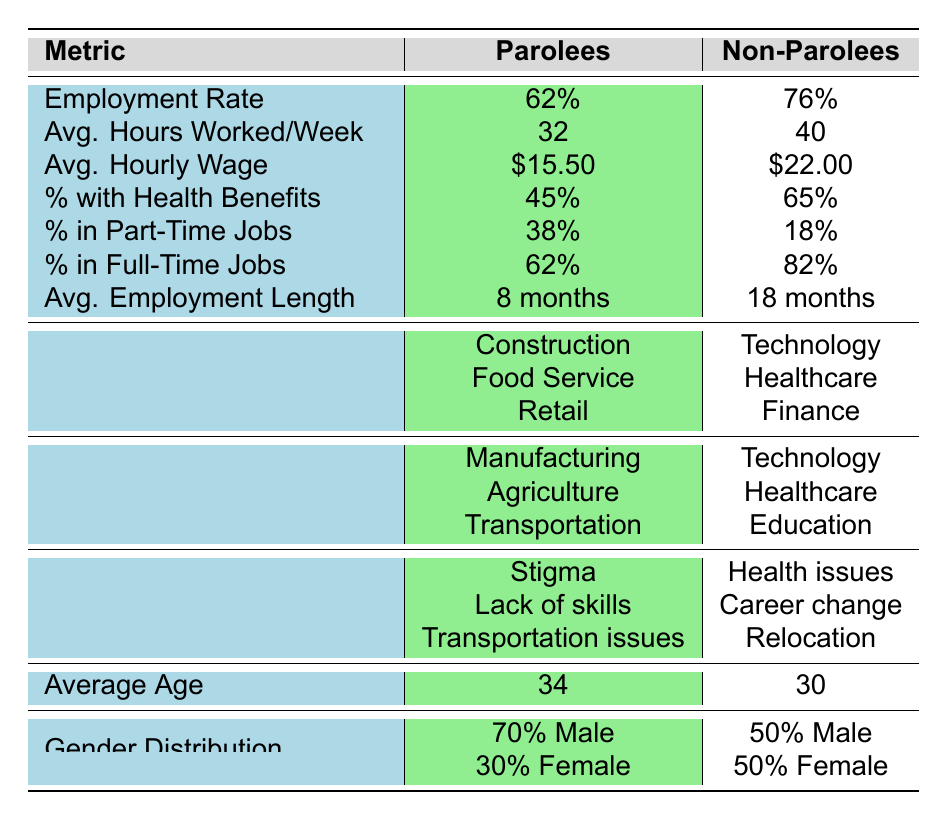What is the employment rate for parolees? The table lists the employment rate for parolees as 62%.
Answer: 62% How many hours do parolees work on average per week? According to the table, parolees work an average of 32 hours per week.
Answer: 32 hours What is the average hourly wage for non-parolees? The table shows that the average hourly wage for non-parolees is $22.00.
Answer: $22.00 What percentage of parolees have health benefits? The table indicates that 45% of parolees have health benefits.
Answer: 45% What is the difference in employment rates between parolees and non-parolees? The employment rate for parolees is 62%, while for non-parolees it is 76%. The difference is 76% - 62% = 14%.
Answer: 14% What percentage of non-parolees are in full-time jobs? The table states that 82% of non-parolees are in full-time jobs.
Answer: 82% What is the average length of employment for parolees compared to non-parolees? Parolees have an average length of employment of 8 months, while non-parolees have 18 months. This shows that non-parolees have a longer average employment length by 10 months.
Answer: 10 months longer Name at least two common industries for parolees. The table lists common industries for parolees as Manufacturing, Agriculture, and Transportation.
Answer: Manufacturing, Agriculture Do more parolees or non-parolees work part-time? The table shows that 38% of parolees work part-time compared to 18% of non-parolees. Therefore, more parolees work part-time.
Answer: More parolees What are the top three reasons for unemployment among parolees? According to the table, the reasons for unemployment among parolees include Stigma, Lack of skills, and Transportation issues.
Answer: Stigma, Lack of skills, Transportation issues How does the average age of parolees compare to that of non-parolees? The average age of parolees is 34 years, while non-parolees are 30 years old. This indicates that parolees are, on average, 4 years older than non-parolees.
Answer: 4 years older Considering both demographic groups, what is the combined percentage of individuals in part-time jobs? For parolees, 38% are in part-time jobs, and for non-parolees, 18% are in part-time jobs. The combined percentage is 38% + 18% = 56%.
Answer: 56% What percentage of non-parolees have health benefits compared to parolees? The table states that 65% of non-parolees have health benefits compared to 45% of parolees. Thus, non-parolees have 20% more individuals with health benefits than parolees.
Answer: 20% more If both groups worked the same average number of hours per week, what would be the average hourly wage required for parolees to match the annual earnings of non-parolees? Non-parolees work 40 hours a week for an average hourly wage of $22.00, leading to an annual earning of 40 * 22 * 52 = $45,760. For parolees, who work 32 hours a week, to achieve the same annual earnings, they would need an hourly wage of $45,760 / (32 * 52) = $27.75.
Answer: $27.75 